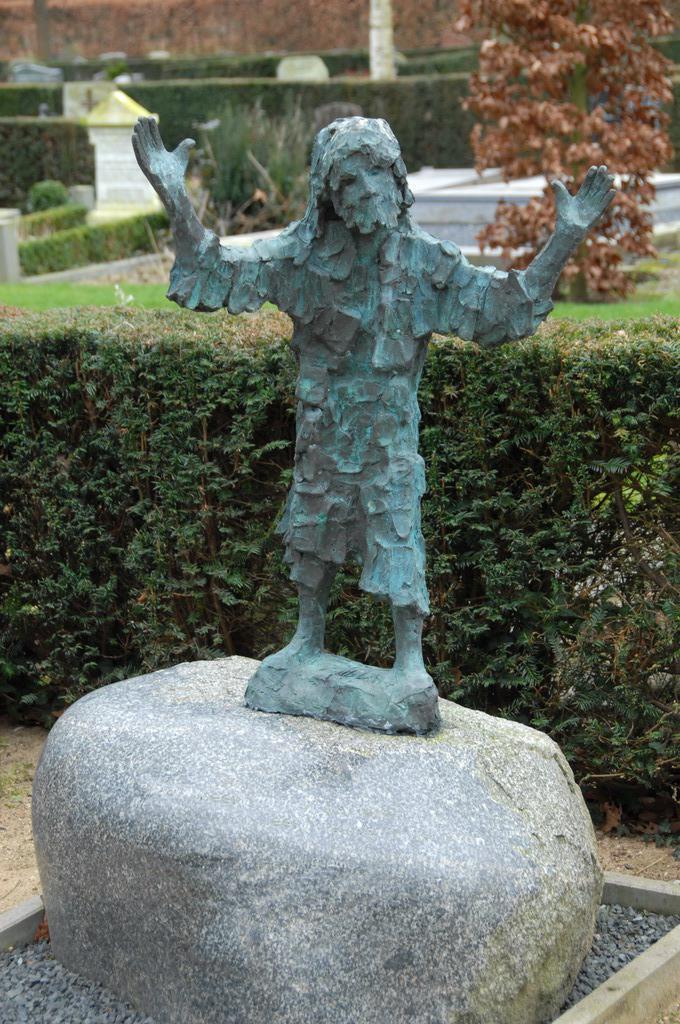In one or two sentences, can you explain what this image depicts? In the image we can see the sculpture of a person standing. Here we can see stones, plants, grass, trees and the background is slightly blurred. 